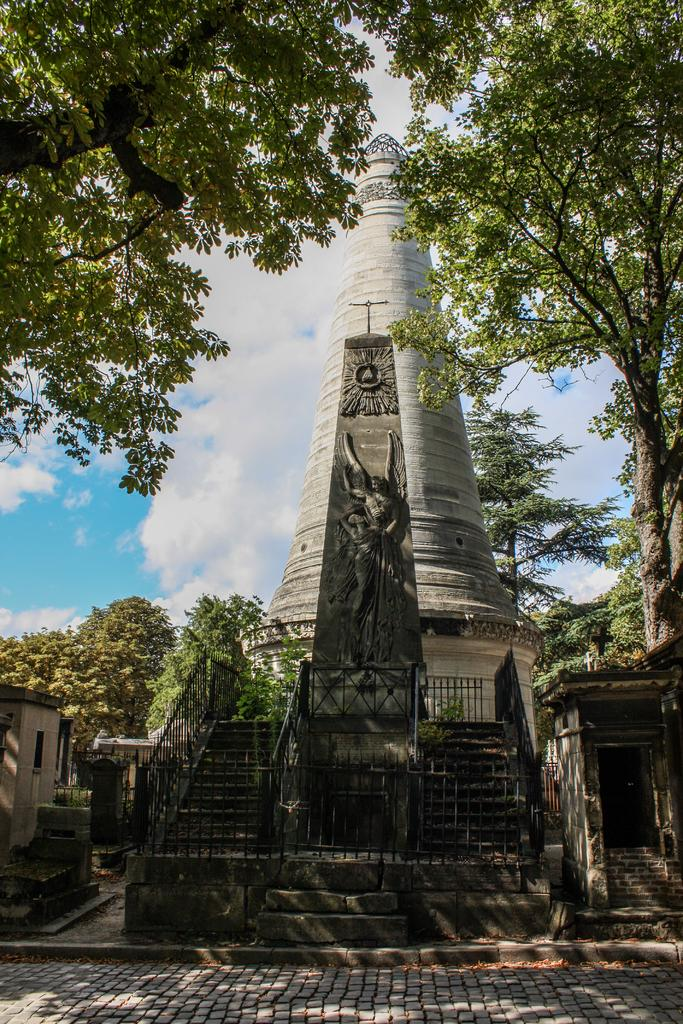What is the main structure in the middle of the image? There is a steeple in the middle of the image. What architectural feature is also present in the middle of the image? There is a staircase in the middle of the image. What is at the bottom of the image? There is a floor at the bottom of the image. What can be seen in the background of the image? There are trees, sky, and clouds visible in the background of the image. How many birds are perched on the finger of the person in the image? There is no person or finger present in the image, so it is not possible to determine the number of birds perched on a finger. 